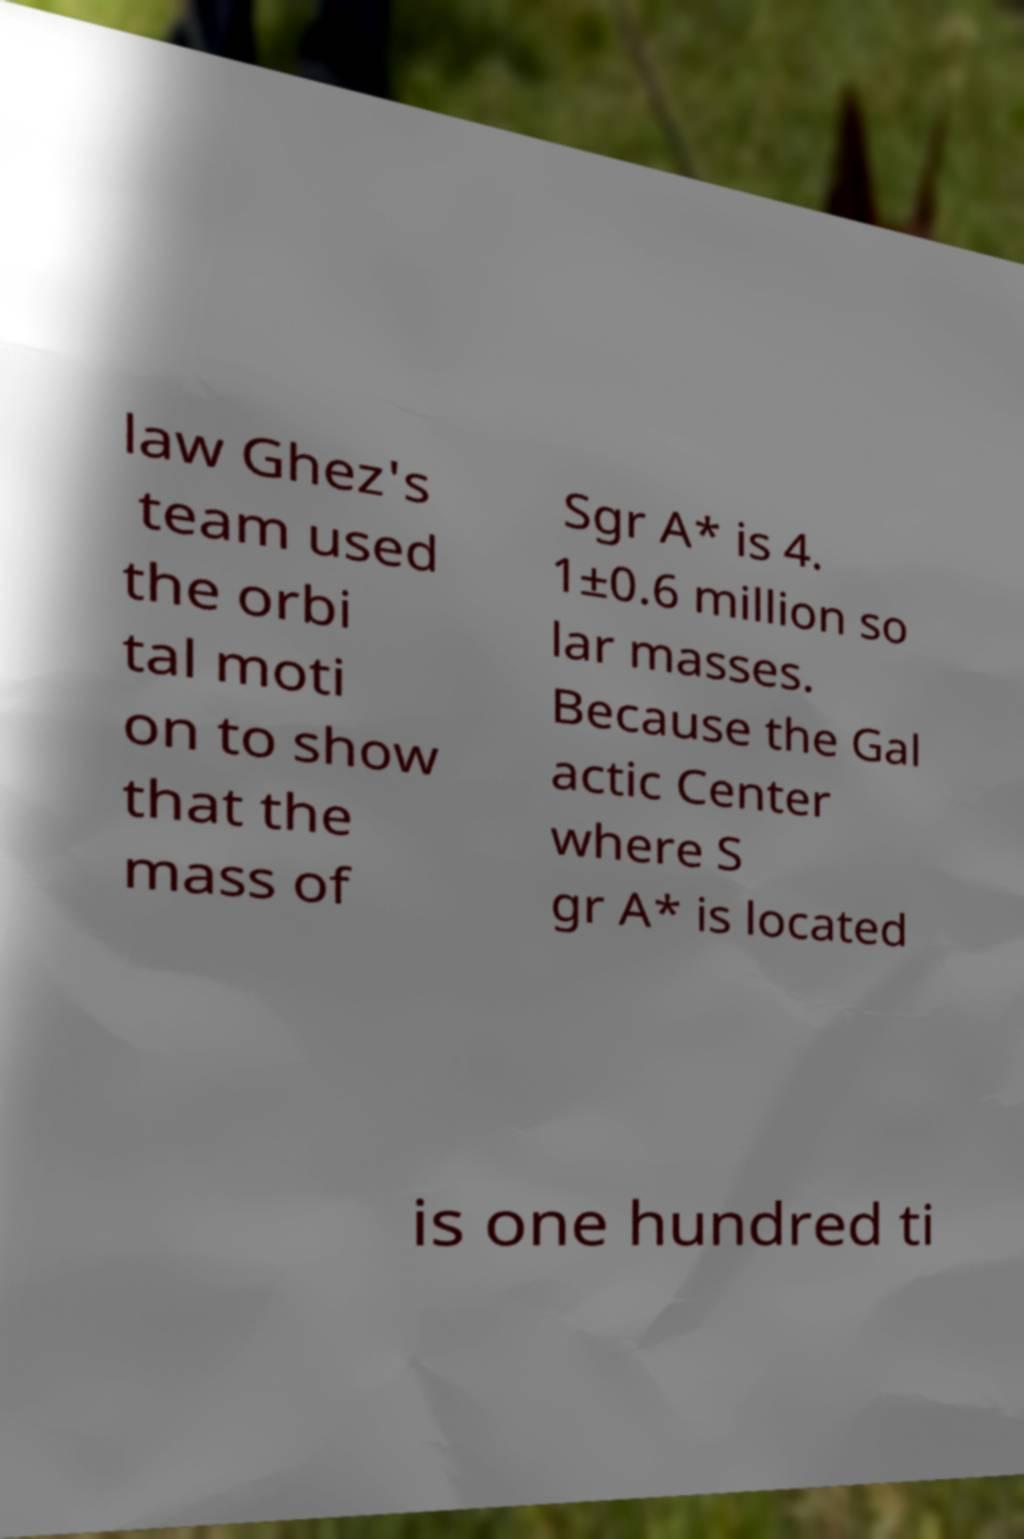Please read and relay the text visible in this image. What does it say? law Ghez's team used the orbi tal moti on to show that the mass of Sgr A* is 4. 1±0.6 million so lar masses. Because the Gal actic Center where S gr A* is located is one hundred ti 